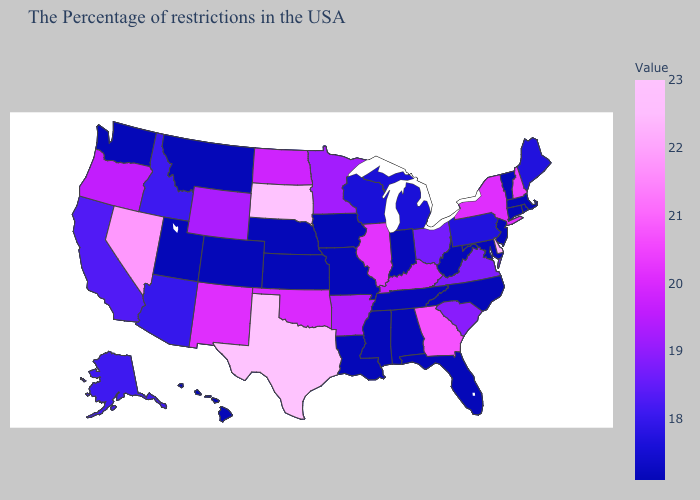Does Maine have the highest value in the Northeast?
Answer briefly. No. Which states have the lowest value in the USA?
Quick response, please. Massachusetts, Rhode Island, Vermont, Connecticut, New Jersey, Maryland, North Carolina, West Virginia, Florida, Indiana, Alabama, Tennessee, Mississippi, Louisiana, Missouri, Iowa, Kansas, Nebraska, Colorado, Utah, Montana, Washington, Hawaii. Does Arizona have the lowest value in the USA?
Keep it brief. No. Is the legend a continuous bar?
Quick response, please. Yes. Does Georgia have the lowest value in the South?
Concise answer only. No. Does Kansas have the highest value in the USA?
Give a very brief answer. No. Does California have the lowest value in the West?
Concise answer only. No. Among the states that border New York , which have the lowest value?
Short answer required. Massachusetts, Vermont, Connecticut, New Jersey. 